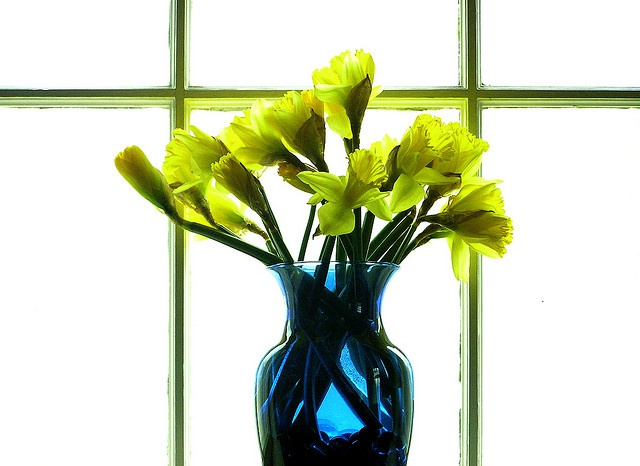Describe the objects in this image and their specific colors. I can see potted plant in white, black, yellow, and olive tones and vase in white, black, navy, teal, and lightblue tones in this image. 